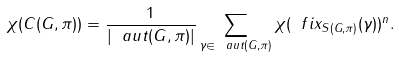<formula> <loc_0><loc_0><loc_500><loc_500>\chi ( C ( G , \pi ) ) = \frac { 1 } { | \ a u t ( G , \pi ) | } \sum _ { \gamma \in \ a u t ( G , \pi ) } \chi ( \ f i x _ { S ( G , \pi ) } ( \gamma ) ) ^ { n } .</formula> 